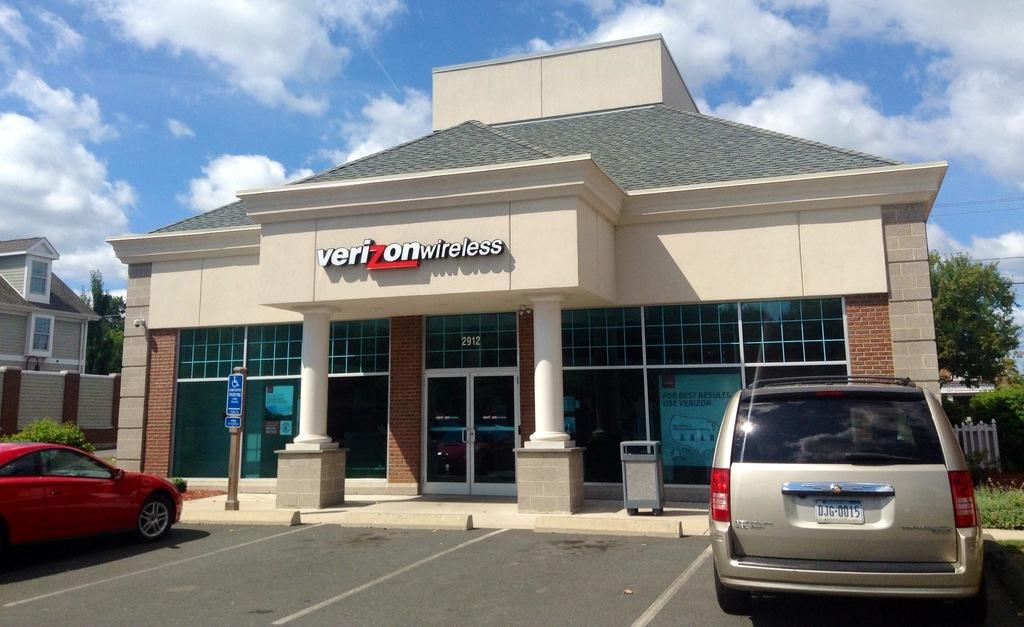How many vehicles can be seen on the road in the image? There are two vehicles on the road in the image. What can be seen in the background of the image? There are buildings, trees, grass, plants, and the sky visible in the background. What type of environment is depicted in the image? The image shows a road with vehicles, surrounded by buildings, trees, and natural vegetation. What type of story is being told by the carriage in the image? There is no carriage present in the image, so no story can be told by a carriage. 